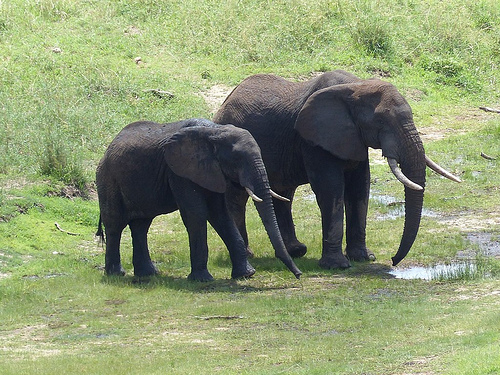What is the animal in the grass? The animal in the grass is an elephant. 